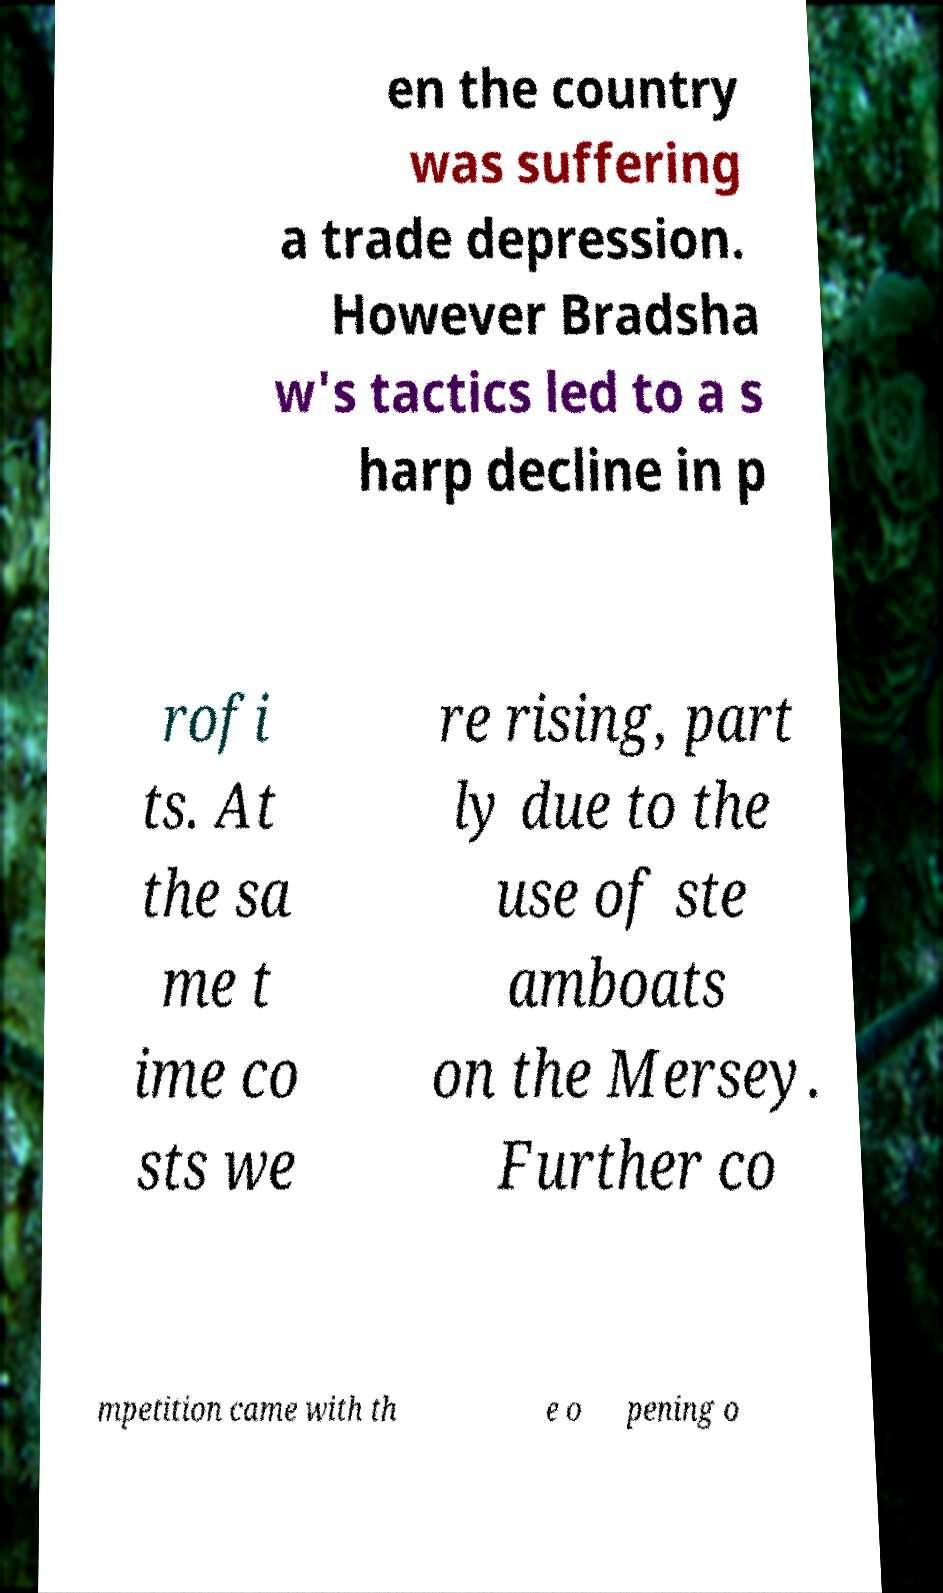There's text embedded in this image that I need extracted. Can you transcribe it verbatim? en the country was suffering a trade depression. However Bradsha w's tactics led to a s harp decline in p rofi ts. At the sa me t ime co sts we re rising, part ly due to the use of ste amboats on the Mersey. Further co mpetition came with th e o pening o 